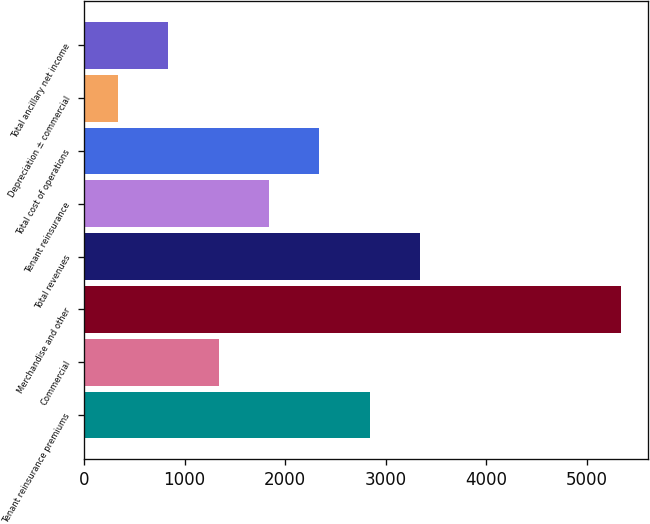Convert chart to OTSL. <chart><loc_0><loc_0><loc_500><loc_500><bar_chart><fcel>Tenant reinsurance premiums<fcel>Commercial<fcel>Merchandise and other<fcel>Total revenues<fcel>Tenant reinsurance<fcel>Total cost of operations<fcel>Depreciation ± commercial<fcel>Total ancillary net income<nl><fcel>2840<fcel>1337.4<fcel>5335<fcel>3339.7<fcel>1837.1<fcel>2336.8<fcel>338<fcel>837.7<nl></chart> 